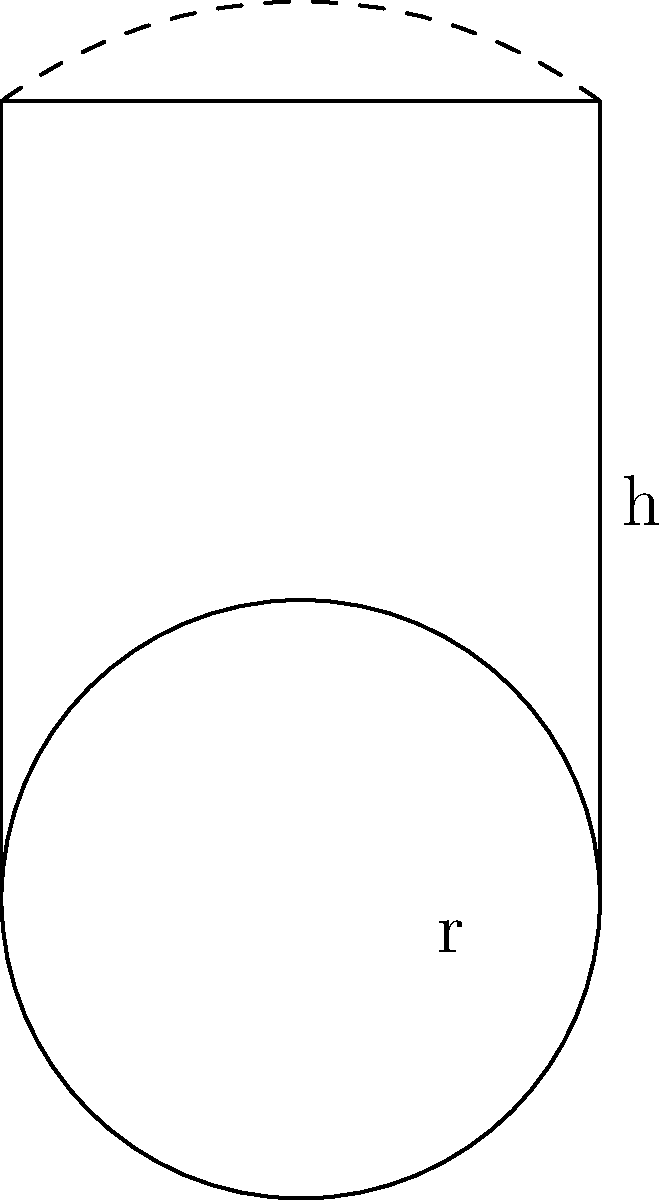As a healthcare administrator, you're tasked with calculating the total surface area of cylindrical medical waste containers to ensure proper disposal protocols. Given a container with radius $r = 1.5$ meters and height $h = 4$ meters, calculate the total surface area. How might the accuracy of this calculation impact the ethical disposal of medical waste? To calculate the total surface area of a cylindrical container, we need to consider both the lateral surface area and the area of the two circular bases.

1. Lateral surface area:
   $A_{lateral} = 2\pi rh$
   $A_{lateral} = 2\pi (1.5)(4) = 12\pi$ m²

2. Area of one circular base:
   $A_{base} = \pi r^2$
   $A_{base} = \pi (1.5)^2 = 2.25\pi$ m²

3. Total surface area:
   $A_{total} = A_{lateral} + 2A_{base}$
   $A_{total} = 12\pi + 2(2.25\pi)$
   $A_{total} = 16.5\pi$ m²

4. Simplify:
   $A_{total} = 16.5\pi \approx 51.84$ m²

The accuracy of this calculation is crucial for ethical waste disposal. Underestimating the surface area could lead to inadequate containment, risking contamination and health hazards. Overestimation might result in excessive use of materials, leading to unnecessary environmental impact and increased costs. Precise calculations ensure compliance with regulations and minimize risks associated with medical waste handling.
Answer: $51.84$ m² 